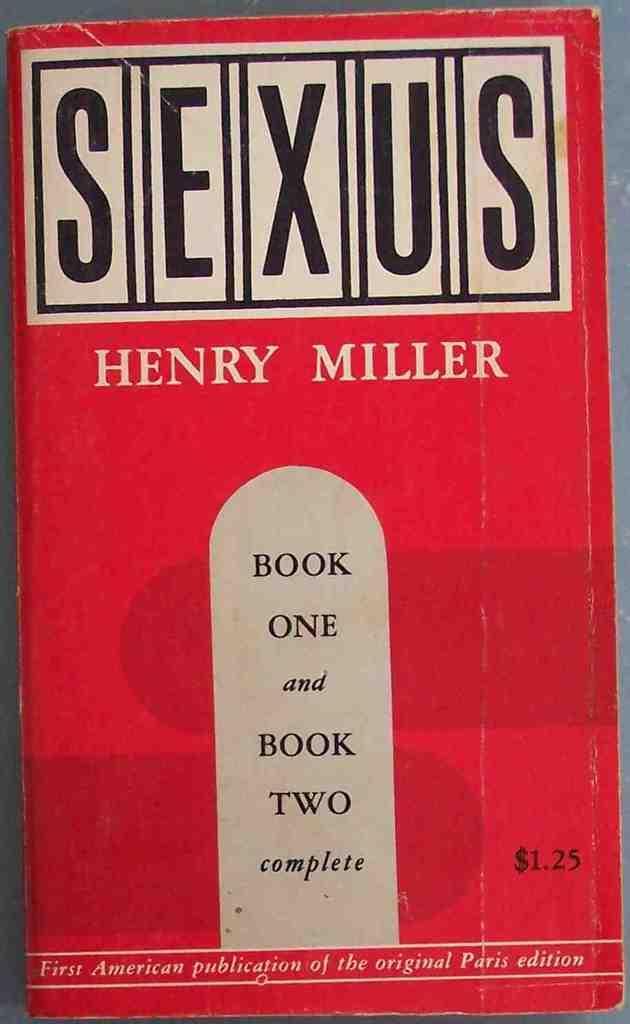Please provide a concise description of this image. In this image we can see a book and we can also see some text written on it. 